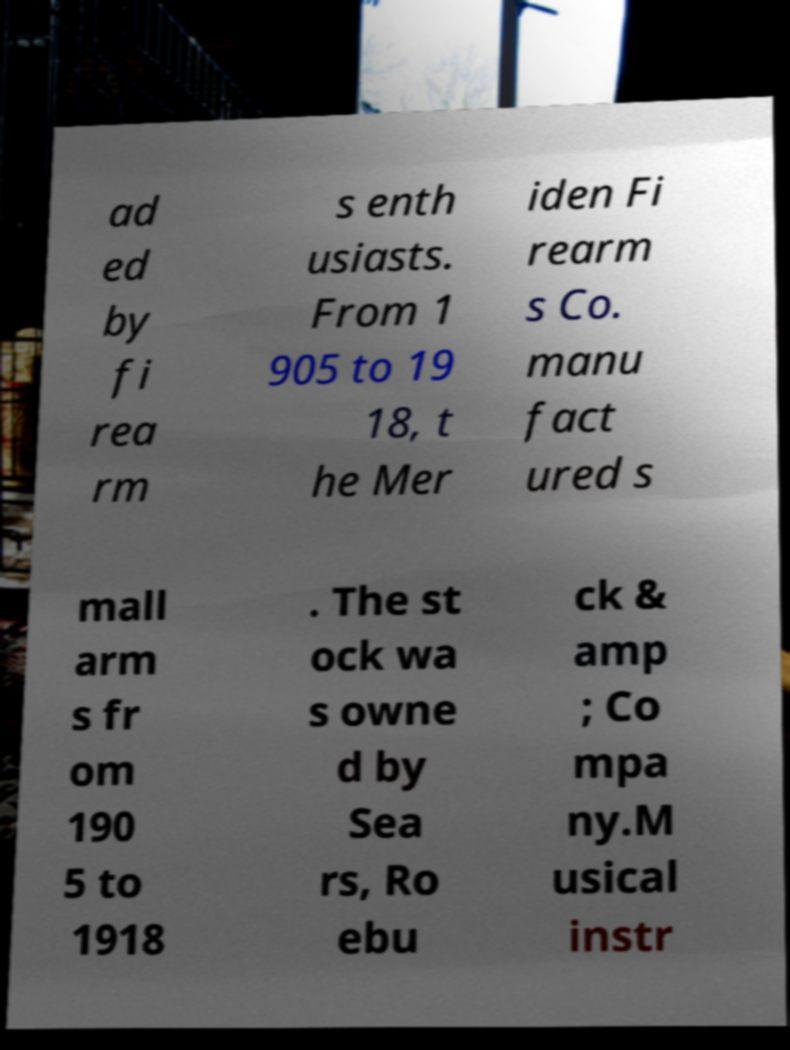Please read and relay the text visible in this image. What does it say? ad ed by fi rea rm s enth usiasts. From 1 905 to 19 18, t he Mer iden Fi rearm s Co. manu fact ured s mall arm s fr om 190 5 to 1918 . The st ock wa s owne d by Sea rs, Ro ebu ck & amp ; Co mpa ny.M usical instr 